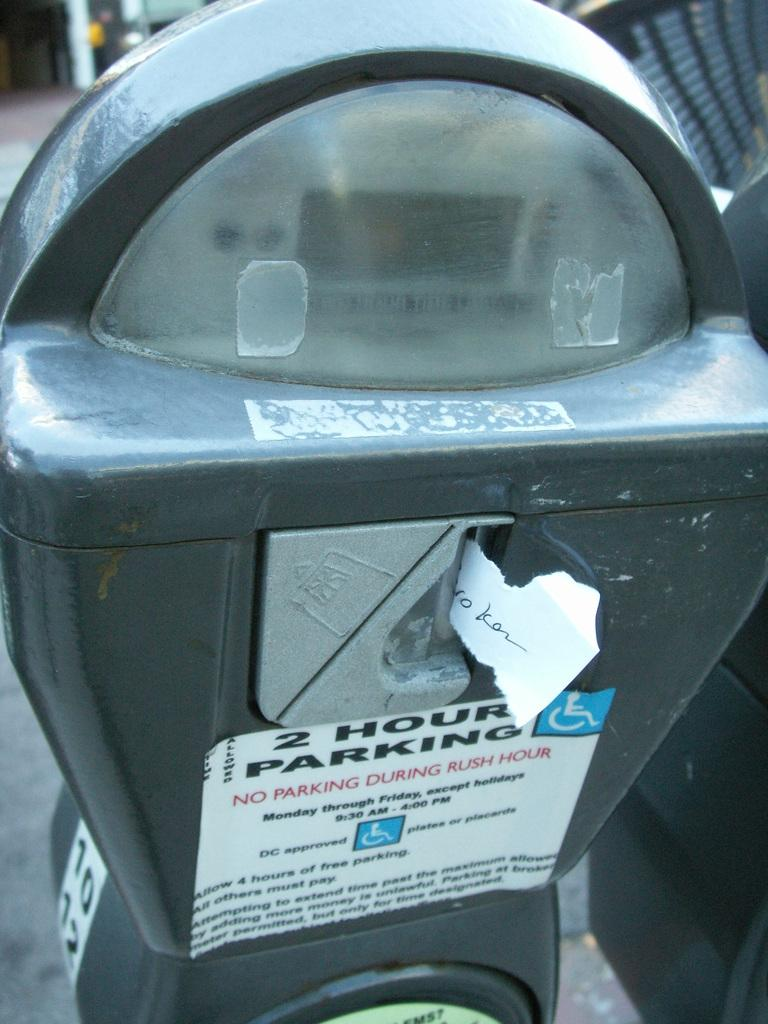<image>
Offer a succinct explanation of the picture presented. A 2 hour parking sticker on a parking meter 